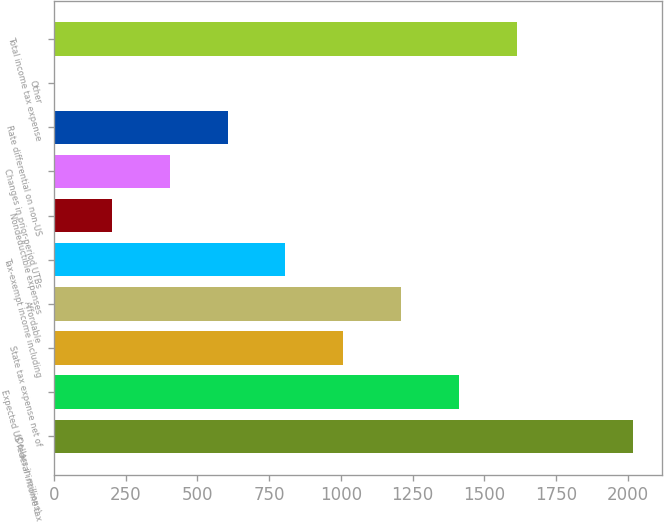Convert chart. <chart><loc_0><loc_0><loc_500><loc_500><bar_chart><fcel>(Dollars in millions)<fcel>Expected US federal income tax<fcel>State tax expense net of<fcel>Affordable<fcel>Tax-exempt income including<fcel>Nondeductible expenses<fcel>Changes in prior-period UTBs<fcel>Rate differential on non-US<fcel>Other<fcel>Total income tax expense<nl><fcel>2017<fcel>1411.96<fcel>1008.6<fcel>1210.28<fcel>806.92<fcel>201.88<fcel>403.56<fcel>605.24<fcel>0.2<fcel>1613.64<nl></chart> 